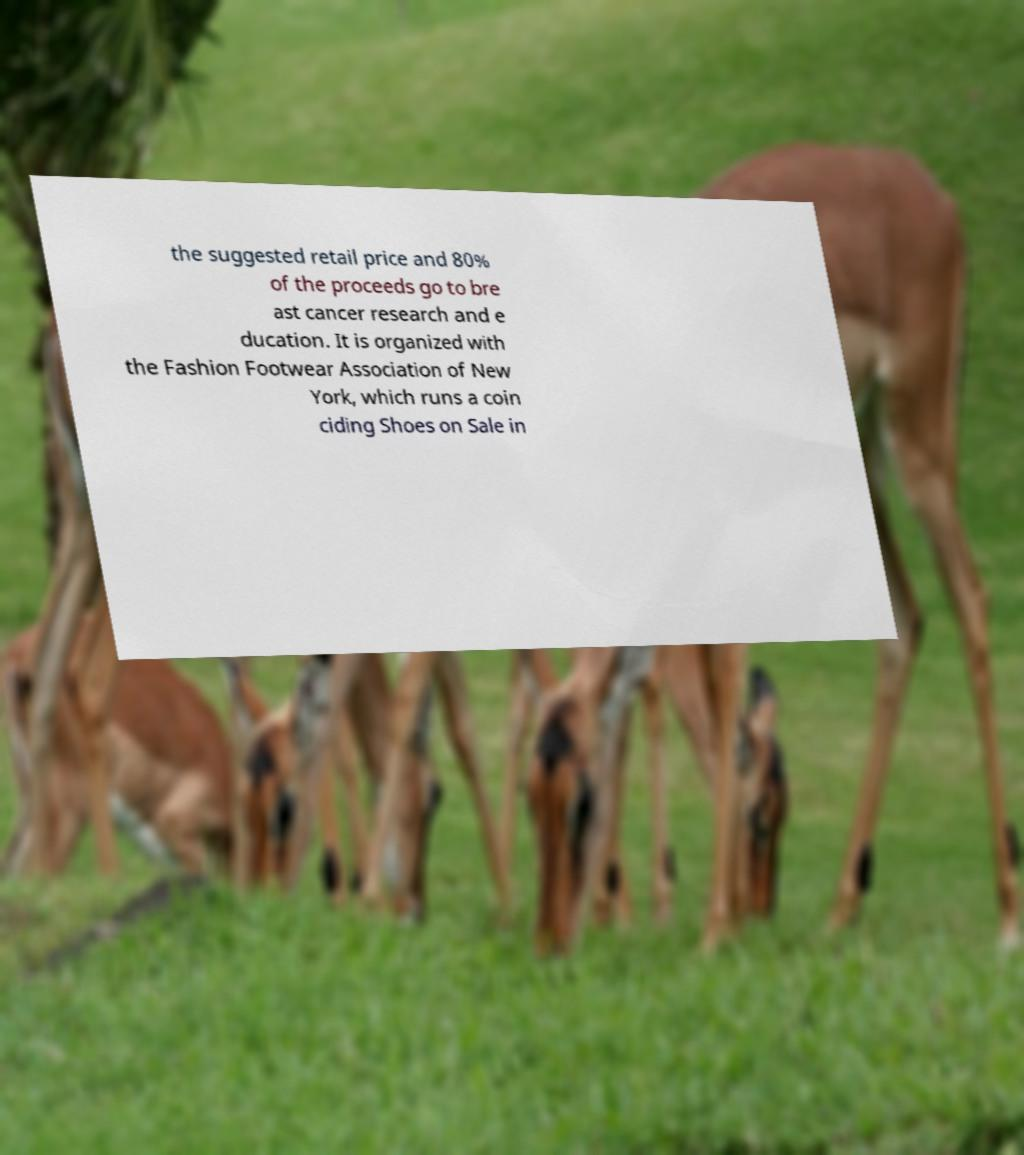Please read and relay the text visible in this image. What does it say? the suggested retail price and 80% of the proceeds go to bre ast cancer research and e ducation. It is organized with the Fashion Footwear Association of New York, which runs a coin ciding Shoes on Sale in 